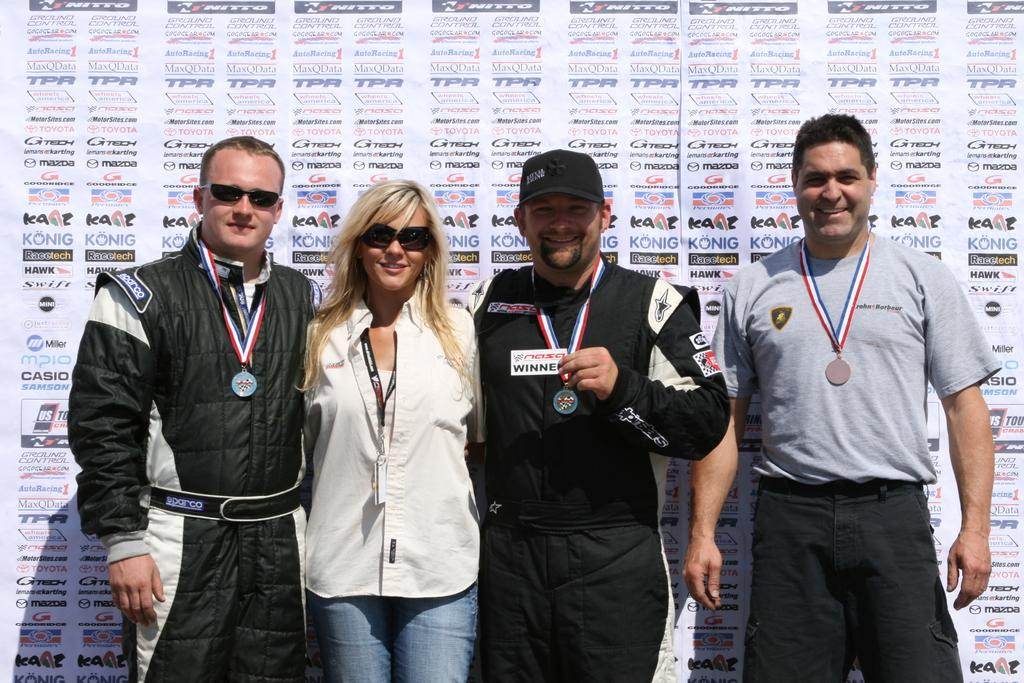How many people are in the image? There are three men and a woman in the image, making a total of four people. What are the people in the image doing? The people are standing, and they have smiling faces. What can be seen in the background of the image? There are posters with text in the background of the image. What type of jar is being used to laugh by the people in the image? There is no jar present in the image, and the people are not using any jar to laugh. 